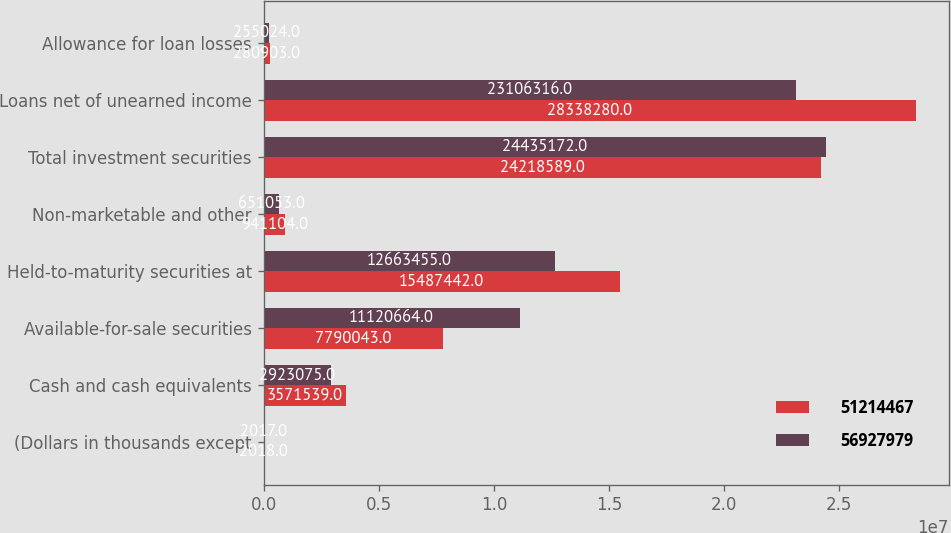<chart> <loc_0><loc_0><loc_500><loc_500><stacked_bar_chart><ecel><fcel>(Dollars in thousands except<fcel>Cash and cash equivalents<fcel>Available-for-sale securities<fcel>Held-to-maturity securities at<fcel>Non-marketable and other<fcel>Total investment securities<fcel>Loans net of unearned income<fcel>Allowance for loan losses<nl><fcel>5.12145e+07<fcel>2018<fcel>3.57154e+06<fcel>7.79004e+06<fcel>1.54874e+07<fcel>941104<fcel>2.42186e+07<fcel>2.83383e+07<fcel>280903<nl><fcel>5.6928e+07<fcel>2017<fcel>2.92308e+06<fcel>1.11207e+07<fcel>1.26635e+07<fcel>651053<fcel>2.44352e+07<fcel>2.31063e+07<fcel>255024<nl></chart> 